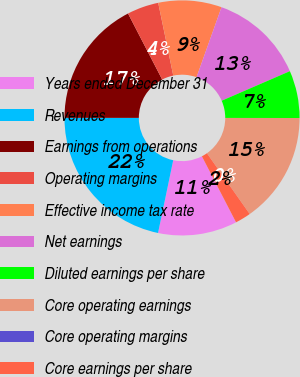<chart> <loc_0><loc_0><loc_500><loc_500><pie_chart><fcel>Years ended December 31<fcel>Revenues<fcel>Earnings from operations<fcel>Operating margins<fcel>Effective income tax rate<fcel>Net earnings<fcel>Diluted earnings per share<fcel>Core operating earnings<fcel>Core operating margins<fcel>Core earnings per share<nl><fcel>10.87%<fcel>21.74%<fcel>17.39%<fcel>4.35%<fcel>8.7%<fcel>13.04%<fcel>6.52%<fcel>15.22%<fcel>0.0%<fcel>2.17%<nl></chart> 